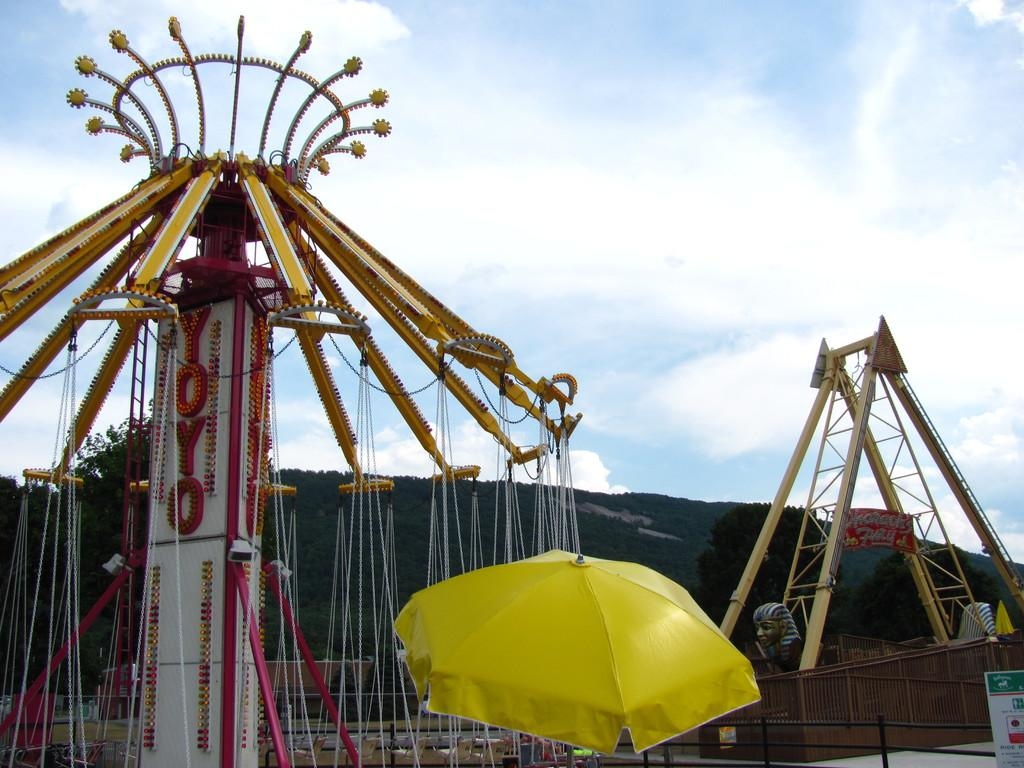What type of attractions can be seen in the image? There are amusement rides in the image. What object is located at the bottom of the image? There is an umbrella at the bottom of the image. What can be seen in the background of the image? There are trees and clouds in the background of the image. Where is the tub located in the image? There is no tub present in the image. How many cherries are hanging from the trees in the background? There is no mention of cherries in the image; only trees are visible in the background. 